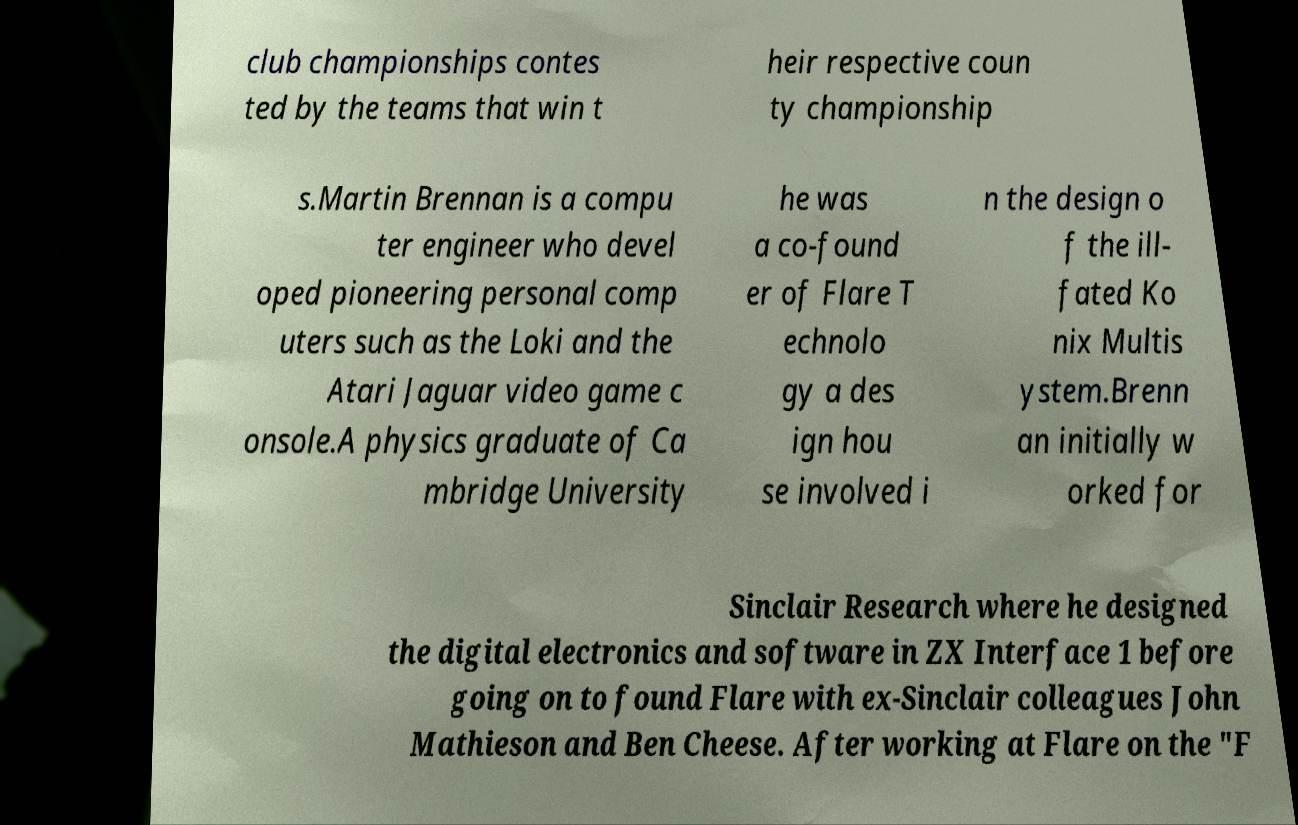Could you assist in decoding the text presented in this image and type it out clearly? club championships contes ted by the teams that win t heir respective coun ty championship s.Martin Brennan is a compu ter engineer who devel oped pioneering personal comp uters such as the Loki and the Atari Jaguar video game c onsole.A physics graduate of Ca mbridge University he was a co-found er of Flare T echnolo gy a des ign hou se involved i n the design o f the ill- fated Ko nix Multis ystem.Brenn an initially w orked for Sinclair Research where he designed the digital electronics and software in ZX Interface 1 before going on to found Flare with ex-Sinclair colleagues John Mathieson and Ben Cheese. After working at Flare on the "F 